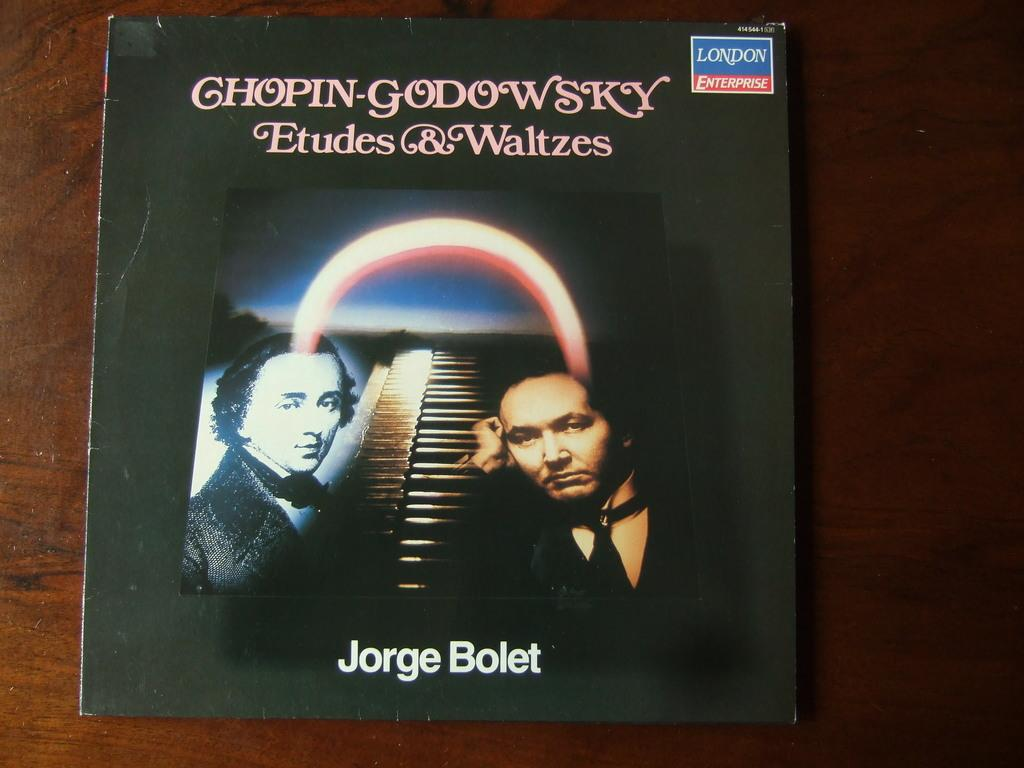What is the main subject of the image? The main subject of the image is an album cover. What type of powder is being used to create the artwork on the album cover? There is no mention of powder or any specific materials used in the creation of the album cover, so we cannot determine what type of powder might be present. 